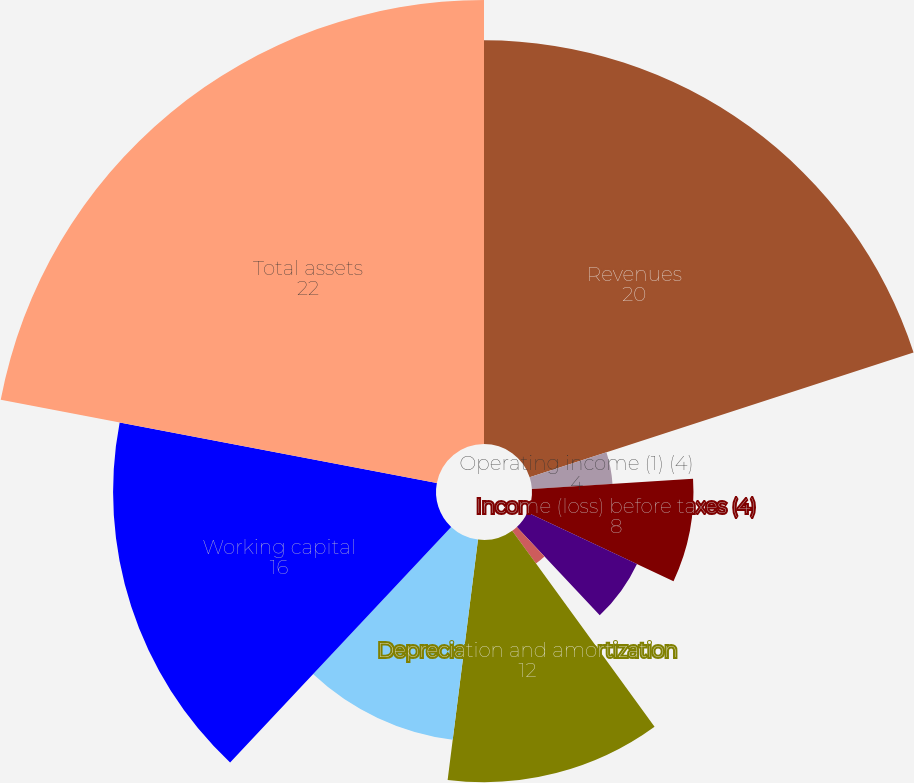Convert chart to OTSL. <chart><loc_0><loc_0><loc_500><loc_500><pie_chart><fcel>Revenues<fcel>Operating income (1) (4)<fcel>Income (loss) before taxes (4)<fcel>Net income (loss) (2)<fcel>Basic (2)<fcel>Diluted (2)<fcel>Depreciation and amortization<fcel>Capital expenditures<fcel>Working capital<fcel>Total assets<nl><fcel>20.0%<fcel>4.0%<fcel>8.0%<fcel>6.0%<fcel>0.0%<fcel>2.0%<fcel>12.0%<fcel>10.0%<fcel>16.0%<fcel>22.0%<nl></chart> 